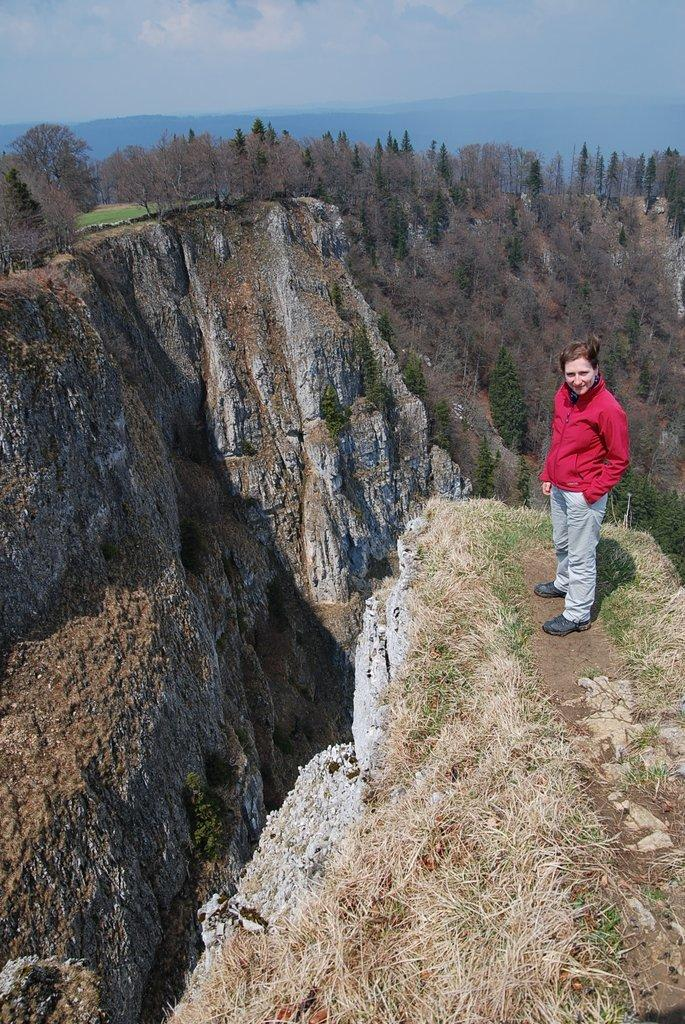Who is the main subject in the image? There is a woman in the image. What is the woman wearing? The woman is wearing a red jacket. Where is the woman located in the image? The woman is standing on a mountain. What can be seen in the background of the image? There are many mountains visible in the background, and they are covered with plants. What is visible at the top of the image? The sky is visible at the top of the image. What type of fuel is being used by the woman in the image? There is no indication in the image that the woman is using any fuel. Is there any snow visible in the image? No, there is no snow visible in the image; the mountains are covered with plants. 